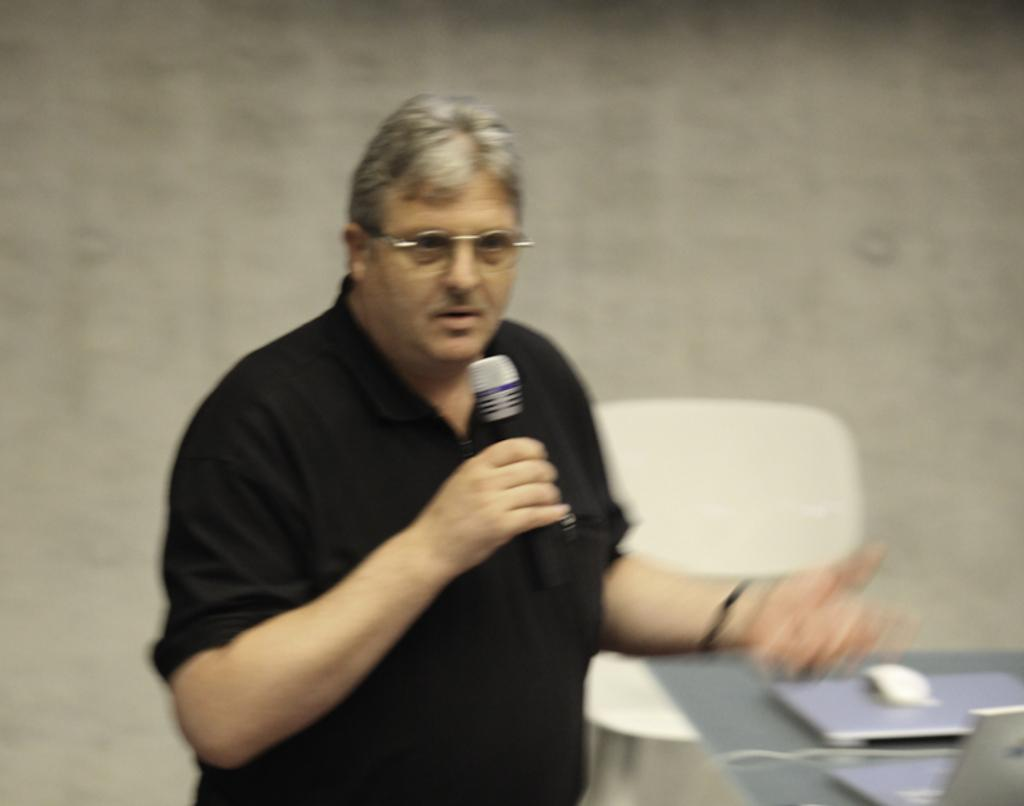What is the person in the image doing? The person is speaking in front of a mic. What is the person wearing in the image? The person is wearing a black shirt. What is the person standing in the image? The person is standing. What objects are on the table in the image? There is a laptop and a mouse on the table. What type of toys can be seen on the table in the image? There are no toys present on the table in the image. What mathematical operation is being performed by the person in the image? There is no indication of any mathematical operation being performed by the person in the image. 